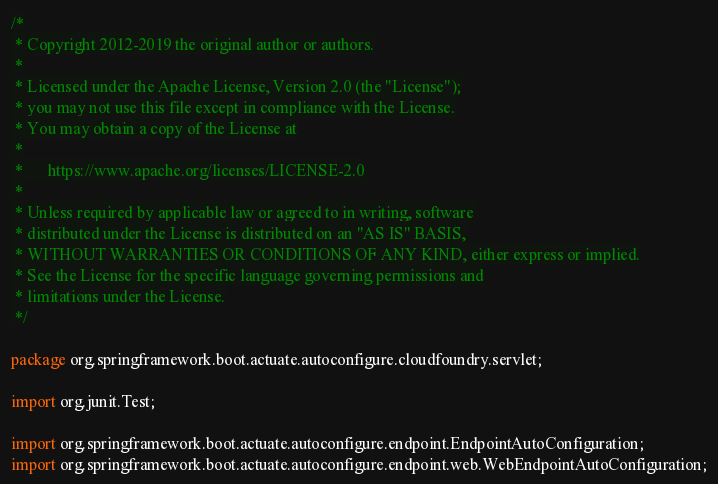Convert code to text. <code><loc_0><loc_0><loc_500><loc_500><_Java_>/*
 * Copyright 2012-2019 the original author or authors.
 *
 * Licensed under the Apache License, Version 2.0 (the "License");
 * you may not use this file except in compliance with the License.
 * You may obtain a copy of the License at
 *
 *      https://www.apache.org/licenses/LICENSE-2.0
 *
 * Unless required by applicable law or agreed to in writing, software
 * distributed under the License is distributed on an "AS IS" BASIS,
 * WITHOUT WARRANTIES OR CONDITIONS OF ANY KIND, either express or implied.
 * See the License for the specific language governing permissions and
 * limitations under the License.
 */

package org.springframework.boot.actuate.autoconfigure.cloudfoundry.servlet;

import org.junit.Test;

import org.springframework.boot.actuate.autoconfigure.endpoint.EndpointAutoConfiguration;
import org.springframework.boot.actuate.autoconfigure.endpoint.web.WebEndpointAutoConfiguration;</code> 